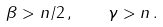<formula> <loc_0><loc_0><loc_500><loc_500>\beta > n / 2 \, , \quad \gamma > n \, .</formula> 